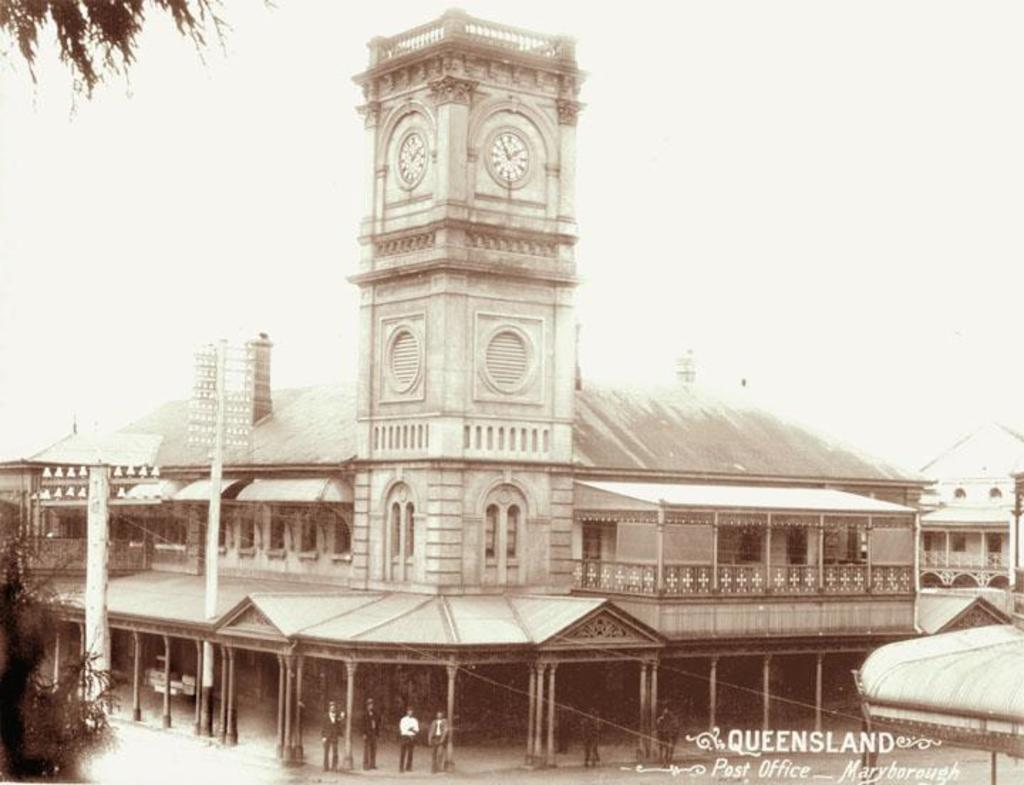What type of structure is visible in the image? There is a building in the image. Who or what can be seen in the image besides the building? There are people and trees visible in the image. Where is the text located in the image? The text is in the bottom right side of the image. How many people are balancing on the pail in the image? There is no pail present in the image, and therefore no one is balancing on it. 